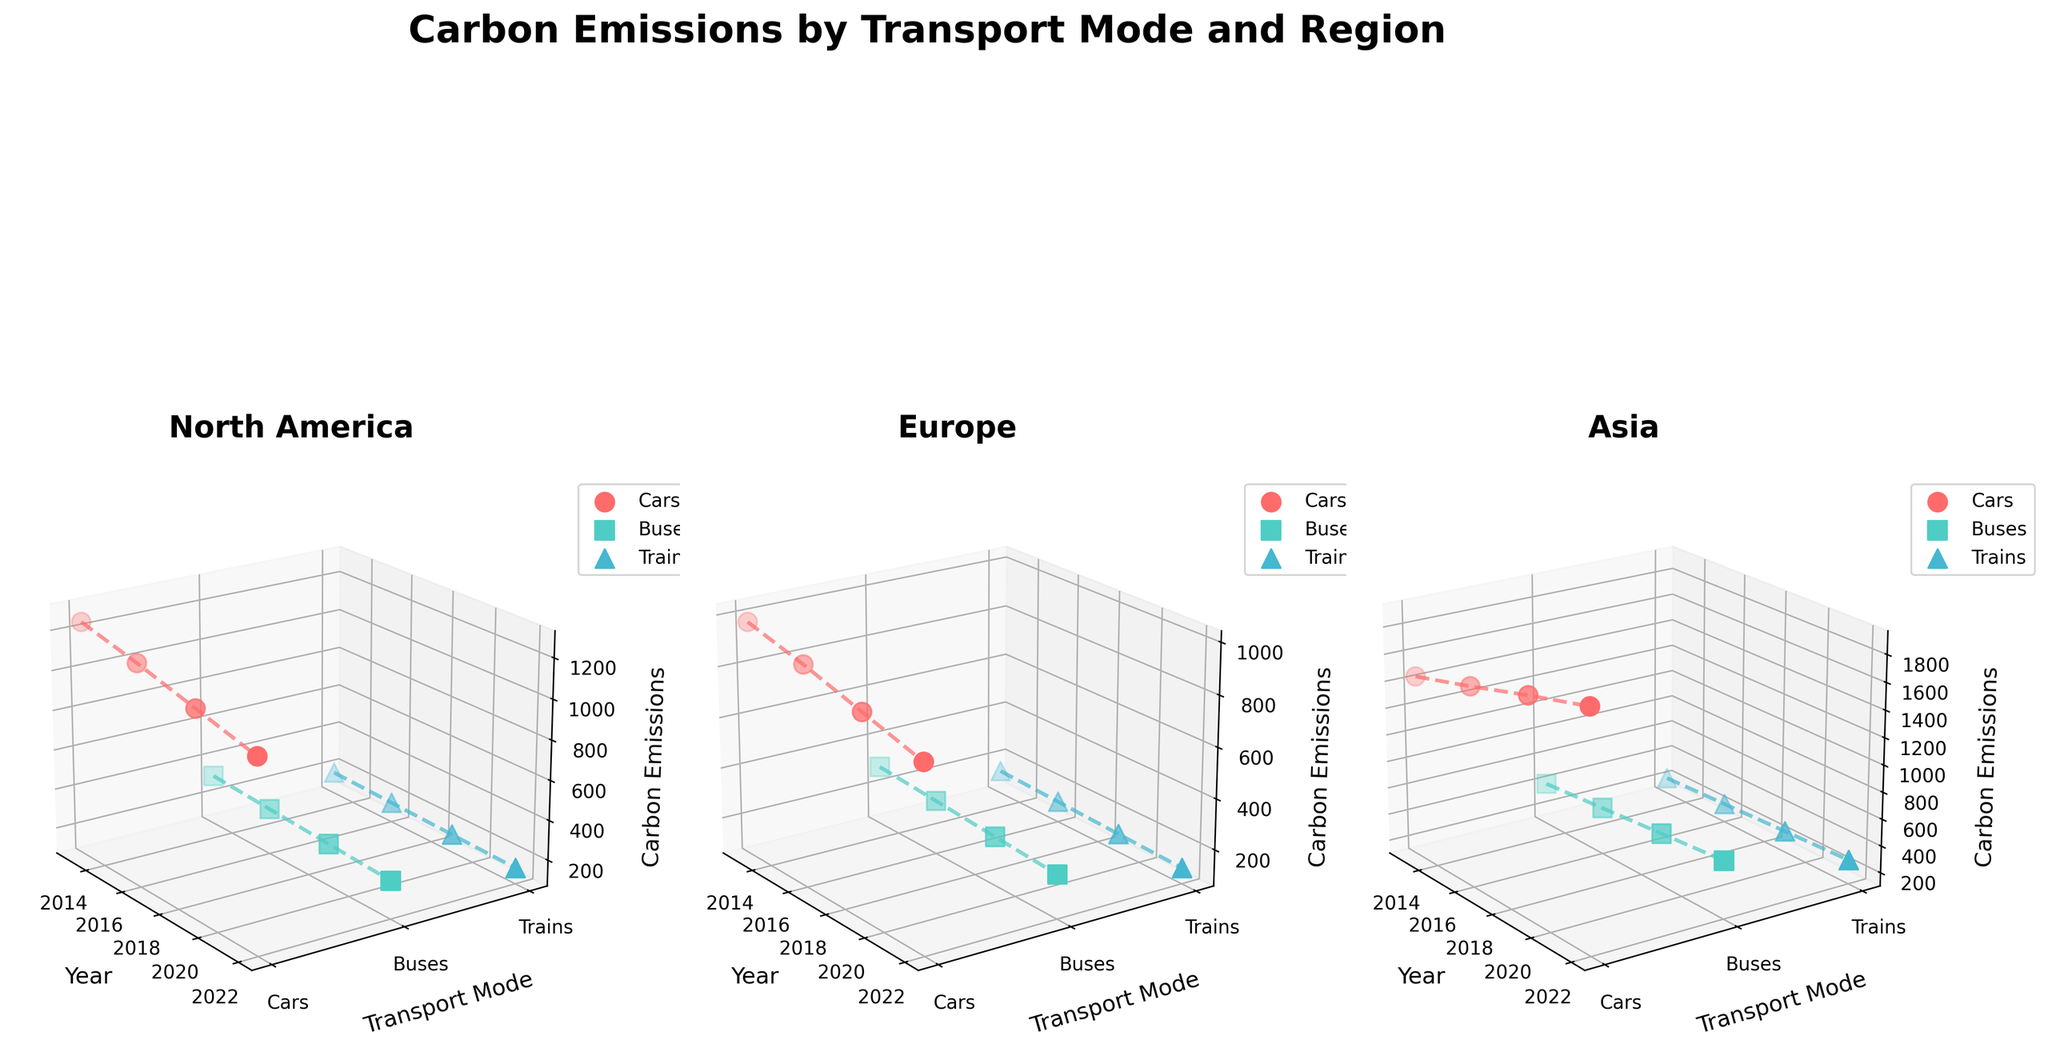What is the title of the figure? The title is typically located at the top of the figure. By reading the title, we can understand the main subject of the visualized data.
Answer: Carbon Emissions by Transport Mode and Region Which region had the highest carbon emissions from cars in 2022? To find this, look at the subplot for 2022 and identify the region with the highest 'z' value for cars.
Answer: Asia How have carbon emissions from buses in Europe changed over the years? Look at the Europe subplot and trace the change in emissions (z-axis) for buses (identified by color and marker) from the start year to the end year.
Answer: They have decreased from 290 in 2013 to 230 in 2022 Between 2016 and 2019, which transport mode in North America saw the biggest decrease in carbon emissions? Compare the z-values for each transport mode in North America between 2016 and 2019. Observe which mode had the greatest drop.
Answer: Cars What is the difference in carbon emissions from trains between North America and Europe in 2019? Locate the train emission values for 2019 in both North America and Europe subplots and compute the difference between them.
Answer: 30 Did the carbon emissions from cars in Asia increase or decrease over the past decade? Check the car emission values in the Asia subplot for the earliest and latest years and compare them.
Answer: Increase Which transport mode had the least variation in carbon emissions in the Europe region over the decade? Examine the changes in emission values on the Europe subplot for each mode and determine which mode's values changed the least.
Answer: Trains Are there any years where the carbon emissions from buses were higher than those from trains in all three regions? By observing the given years, compare the respective values of buses and trains in each subplot to identify any such common year(s).
Answer: Yes, in 2013, 2016, 2019, and 2022 Which transportation mode saw the most consistent reduction in carbon emissions in North America over the decade? In the North America subplot, check the emission values for each mode across the years to identify the one with a consistent downward trend.
Answer: Cars What is the overall trend for carbon emissions from trains across all regions over the decade? In each subplot, track the trend of emissions for trains over the years to determine the general direction (increasing or decreasing).
Answer: Decreasing 